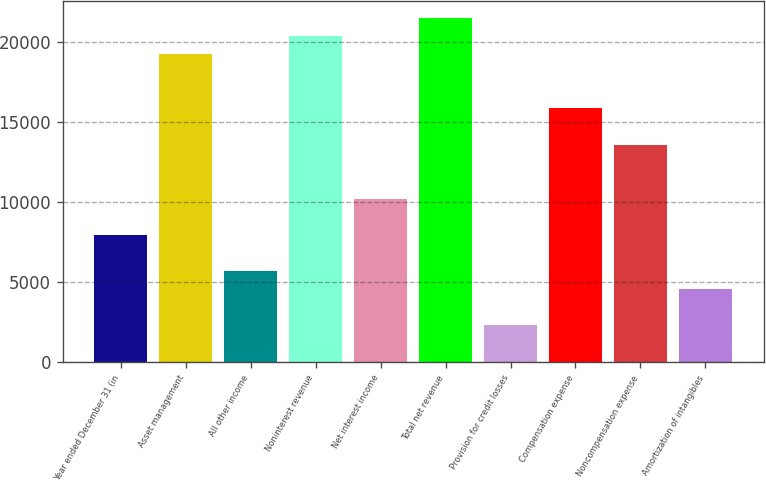Convert chart to OTSL. <chart><loc_0><loc_0><loc_500><loc_500><bar_chart><fcel>Year ended December 31 (in<fcel>Asset management<fcel>All other income<fcel>Noninterest revenue<fcel>Net interest income<fcel>Total net revenue<fcel>Provision for credit losses<fcel>Compensation expense<fcel>Noncompensation expense<fcel>Amortization of intangibles<nl><fcel>7930.9<fcel>19227.9<fcel>5671.5<fcel>20357.6<fcel>10190.3<fcel>21487.3<fcel>2282.4<fcel>15838.8<fcel>13579.4<fcel>4541.8<nl></chart> 